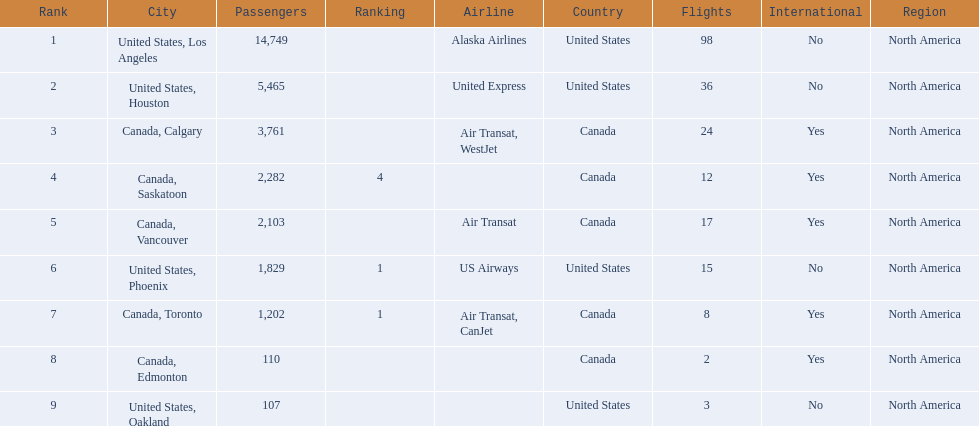What are all the cities? United States, Los Angeles, United States, Houston, Canada, Calgary, Canada, Saskatoon, Canada, Vancouver, United States, Phoenix, Canada, Toronto, Canada, Edmonton, United States, Oakland. Parse the table in full. {'header': ['Rank', 'City', 'Passengers', 'Ranking', 'Airline', 'Country', 'Flights', 'International', 'Region'], 'rows': [['1', 'United States, Los Angeles', '14,749', '', 'Alaska Airlines', 'United States', '98', 'No', 'North America'], ['2', 'United States, Houston', '5,465', '', 'United Express', 'United States', '36', 'No', 'North America'], ['3', 'Canada, Calgary', '3,761', '', 'Air Transat, WestJet', 'Canada', '24', 'Yes', 'North America'], ['4', 'Canada, Saskatoon', '2,282', '4', '', 'Canada', '12', 'Yes', 'North America'], ['5', 'Canada, Vancouver', '2,103', '', 'Air Transat', 'Canada', '17', 'Yes', 'North America'], ['6', 'United States, Phoenix', '1,829', '1', 'US Airways', 'United States', '15', 'No', 'North America'], ['7', 'Canada, Toronto', '1,202', '1', 'Air Transat, CanJet', 'Canada', '8', 'Yes', 'North America'], ['8', 'Canada, Edmonton', '110', '', '', 'Canada', '2', 'Yes', 'North America'], ['9', 'United States, Oakland', '107', '', '', 'United States', '3', 'No', 'North America']]} How many passengers do they service? 14,749, 5,465, 3,761, 2,282, 2,103, 1,829, 1,202, 110, 107. Which city, when combined with los angeles, totals nearly 19,000? Canada, Calgary. 